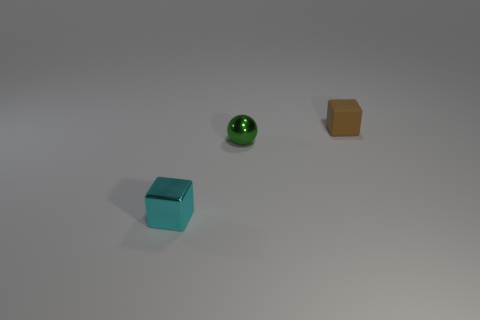Add 1 small metal objects. How many objects exist? 4 Subtract all cubes. How many objects are left? 1 Subtract 0 gray cubes. How many objects are left? 3 Subtract all tiny yellow cubes. Subtract all tiny green metallic balls. How many objects are left? 2 Add 1 matte objects. How many matte objects are left? 2 Add 1 tiny brown spheres. How many tiny brown spheres exist? 1 